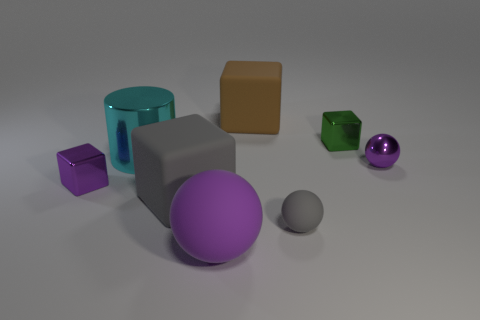Can you describe the positioning of the colored objects in relation to the large gray box in the center? The large gray box is centrally located. To the right, there's a purple ball and further to the right, a smaller green cube. In front of the gray box, slightly to the left, there's a small gray sphere. A large teal cylinder sits on the back left, with a small purple cube in front of it, both aligned to the left of the gray box. 